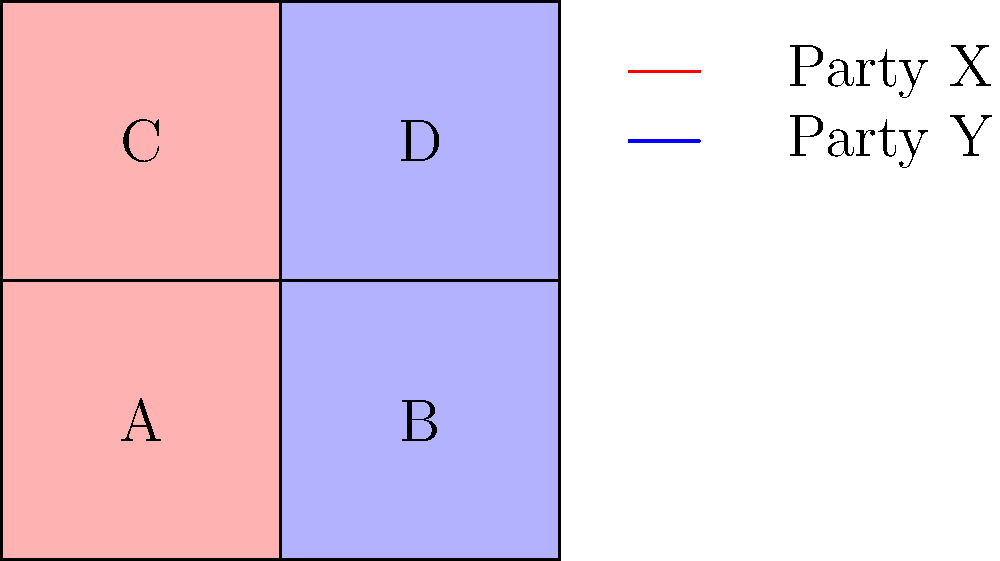In the gerrymandered district map shown above, Party X (red) wins districts A and C, while Party Y (blue) wins districts B and D. The total votes cast in each district are as follows: A: 1000, B: 1200, C: 800, D: 1000. If Party X received 55% of the total votes across all districts, calculate the efficiency gap for this electoral map. To calculate the efficiency gap, we need to follow these steps:

1. Calculate the total votes:
   Total votes = 1000 + 1200 + 800 + 1000 = 4000

2. Calculate votes for each party:
   Party X votes = 55% of 4000 = 0.55 × 4000 = 2200
   Party Y votes = 45% of 4000 = 0.45 × 4000 = 1800

3. Calculate wasted votes for each party:
   Party X wasted votes:
   - In districts A and C (won): (votes - 50% of district total) = (1100 - 500) + (800 - 400) = 1000
   - In districts B and D (lost): all votes = 550 + 550 = 1100
   Total X wasted: 1000 + 1100 = 2100

   Party Y wasted votes:
   - In districts B and D (won): (votes - 50% of district total) = (650 - 600) + (450 - 500) = 0
   - In districts A and C (lost): all votes = 450 + 350 = 800
   Total Y wasted: 0 + 800 = 800

4. Calculate the efficiency gap:
   Efficiency Gap = $(|X_{wasted} - Y_{wasted}|) / (Total Votes)$
   $= (|2100 - 800|) / 4000$
   $= 1300 / 4000$
   $= 0.325$ or 32.5%
Answer: 32.5% 